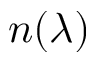<formula> <loc_0><loc_0><loc_500><loc_500>n ( \lambda )</formula> 